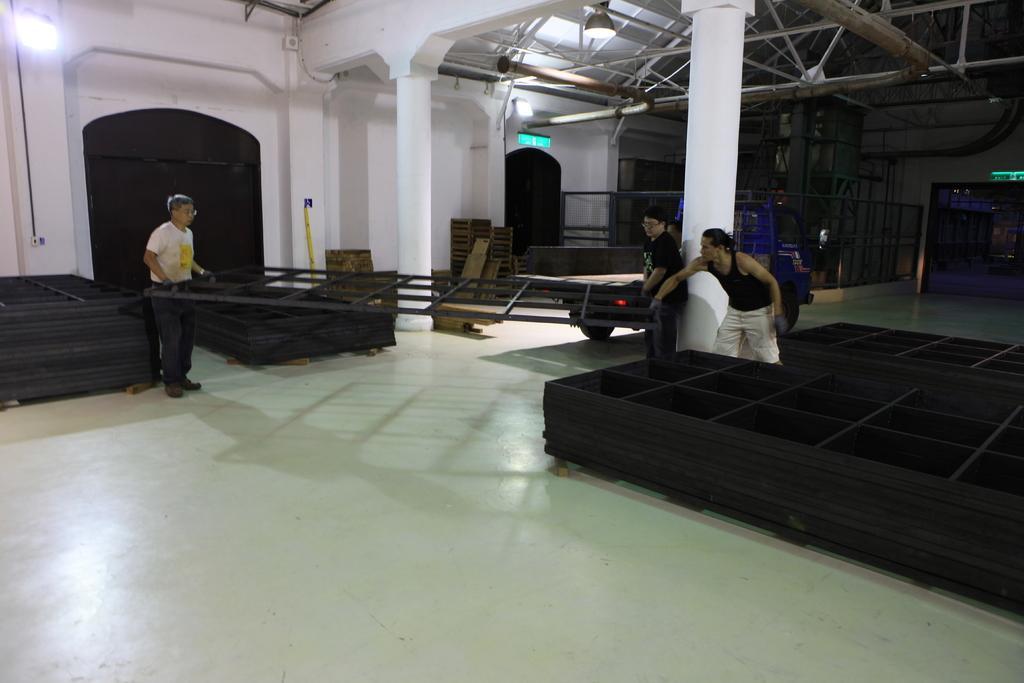Can you describe this image briefly? In the foreground of this image, in the middle, there are black grills like objects on the floor. We can also see three men holding a grill. In the background, there is a vehicle, few wooden objects, wall, doors, lights and ceiling of the shelter. 